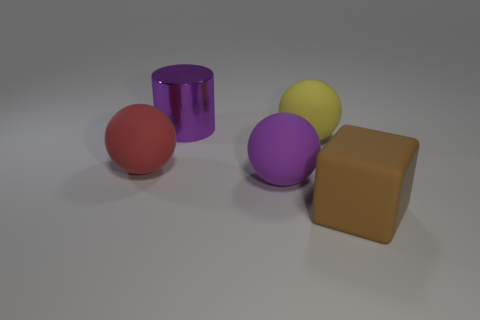Add 4 metal objects. How many objects exist? 9 Subtract all red balls. How many balls are left? 2 Subtract all cylinders. How many objects are left? 4 Subtract 2 spheres. How many spheres are left? 1 Subtract all blue cylinders. How many purple spheres are left? 1 Subtract all large brown cylinders. Subtract all matte spheres. How many objects are left? 2 Add 4 metallic things. How many metallic things are left? 5 Add 3 yellow rubber things. How many yellow rubber things exist? 4 Subtract 1 brown cubes. How many objects are left? 4 Subtract all yellow balls. Subtract all cyan cylinders. How many balls are left? 2 